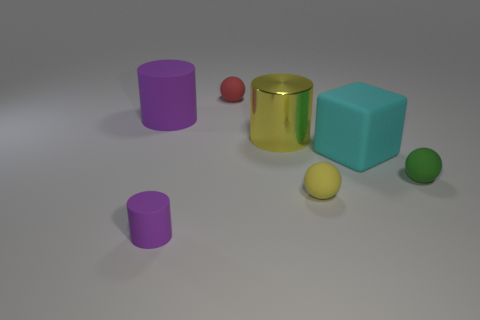Add 2 green cylinders. How many objects exist? 9 Subtract all red matte balls. How many balls are left? 2 Subtract 1 cubes. How many cubes are left? 0 Subtract all red balls. How many balls are left? 2 Subtract all yellow cylinders. Subtract all brown balls. How many cylinders are left? 2 Subtract all cyan spheres. How many purple cylinders are left? 2 Subtract all big cubes. Subtract all purple shiny cylinders. How many objects are left? 6 Add 5 small purple things. How many small purple things are left? 6 Add 5 big gray rubber blocks. How many big gray rubber blocks exist? 5 Subtract 0 cyan cylinders. How many objects are left? 7 